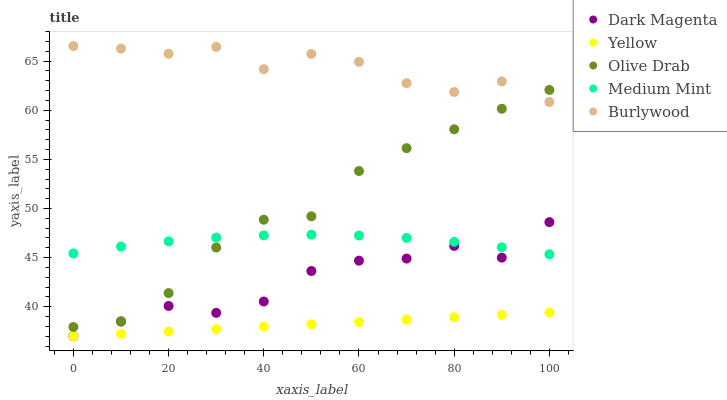Does Yellow have the minimum area under the curve?
Answer yes or no. Yes. Does Burlywood have the maximum area under the curve?
Answer yes or no. Yes. Does Olive Drab have the minimum area under the curve?
Answer yes or no. No. Does Olive Drab have the maximum area under the curve?
Answer yes or no. No. Is Yellow the smoothest?
Answer yes or no. Yes. Is Burlywood the roughest?
Answer yes or no. Yes. Is Olive Drab the smoothest?
Answer yes or no. No. Is Olive Drab the roughest?
Answer yes or no. No. Does Dark Magenta have the lowest value?
Answer yes or no. Yes. Does Olive Drab have the lowest value?
Answer yes or no. No. Does Burlywood have the highest value?
Answer yes or no. Yes. Does Olive Drab have the highest value?
Answer yes or no. No. Is Yellow less than Burlywood?
Answer yes or no. Yes. Is Medium Mint greater than Yellow?
Answer yes or no. Yes. Does Burlywood intersect Olive Drab?
Answer yes or no. Yes. Is Burlywood less than Olive Drab?
Answer yes or no. No. Is Burlywood greater than Olive Drab?
Answer yes or no. No. Does Yellow intersect Burlywood?
Answer yes or no. No. 